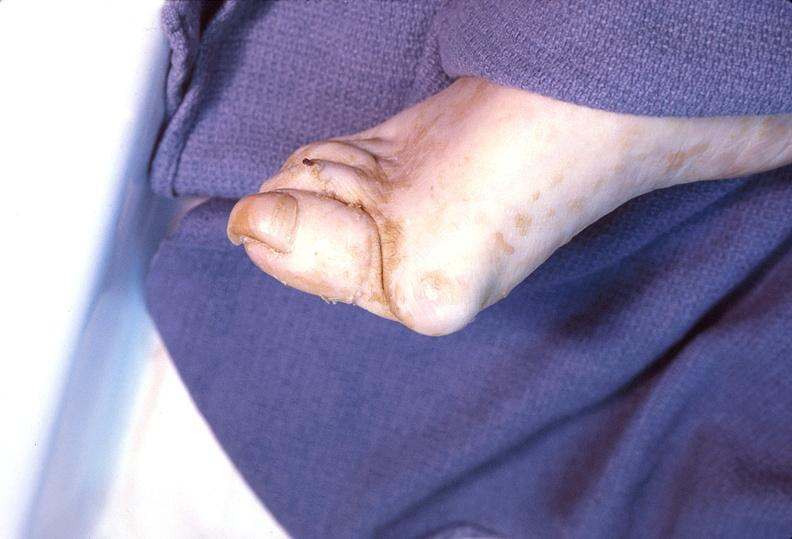does this image show foot, rheumatoid arthritis?
Answer the question using a single word or phrase. Yes 